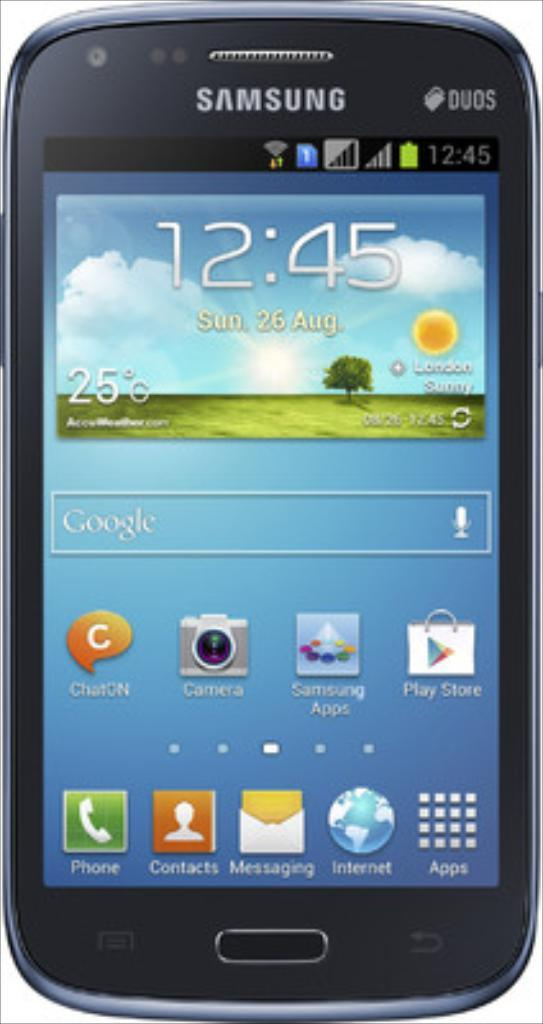<image>
Create a compact narrative representing the image presented. A Samsung mobile device at 12:45 on August 26. 